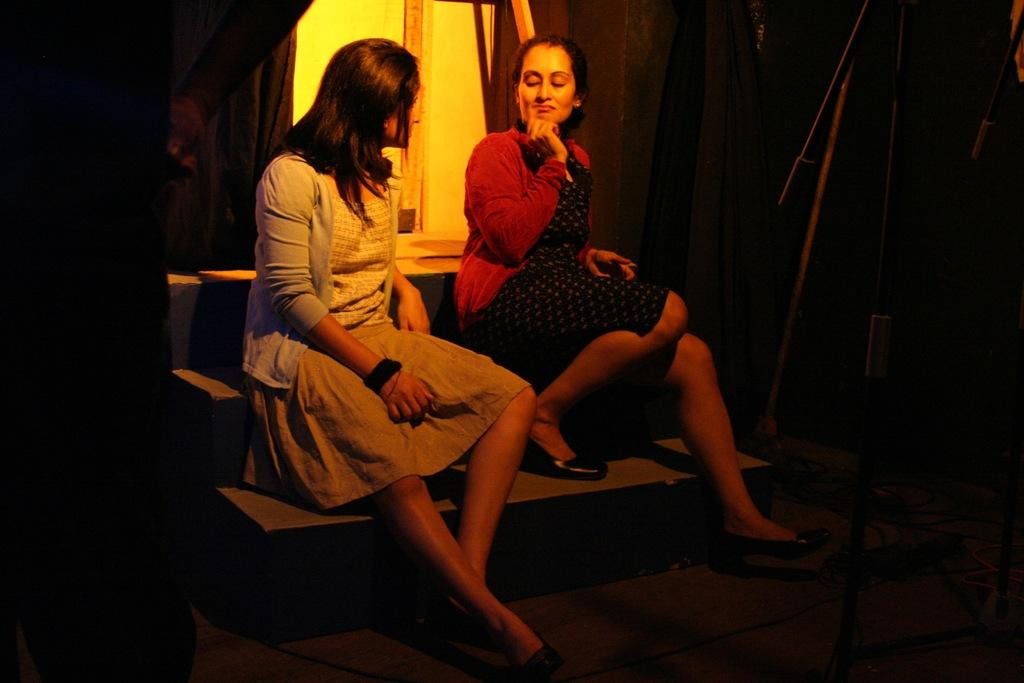What are the women in the image doing? The two women are sitting on the stairs in the image. What can be seen on the right side of the image? There are stands and wires on the right side of the image. What is visible in the background of the image? There appears to be a door in the background of the image. How many hearts can be seen in the image? There are no hearts visible in the image. What type of poison is being used by the women in the image? There is no indication of poison or any such substance in the image. 